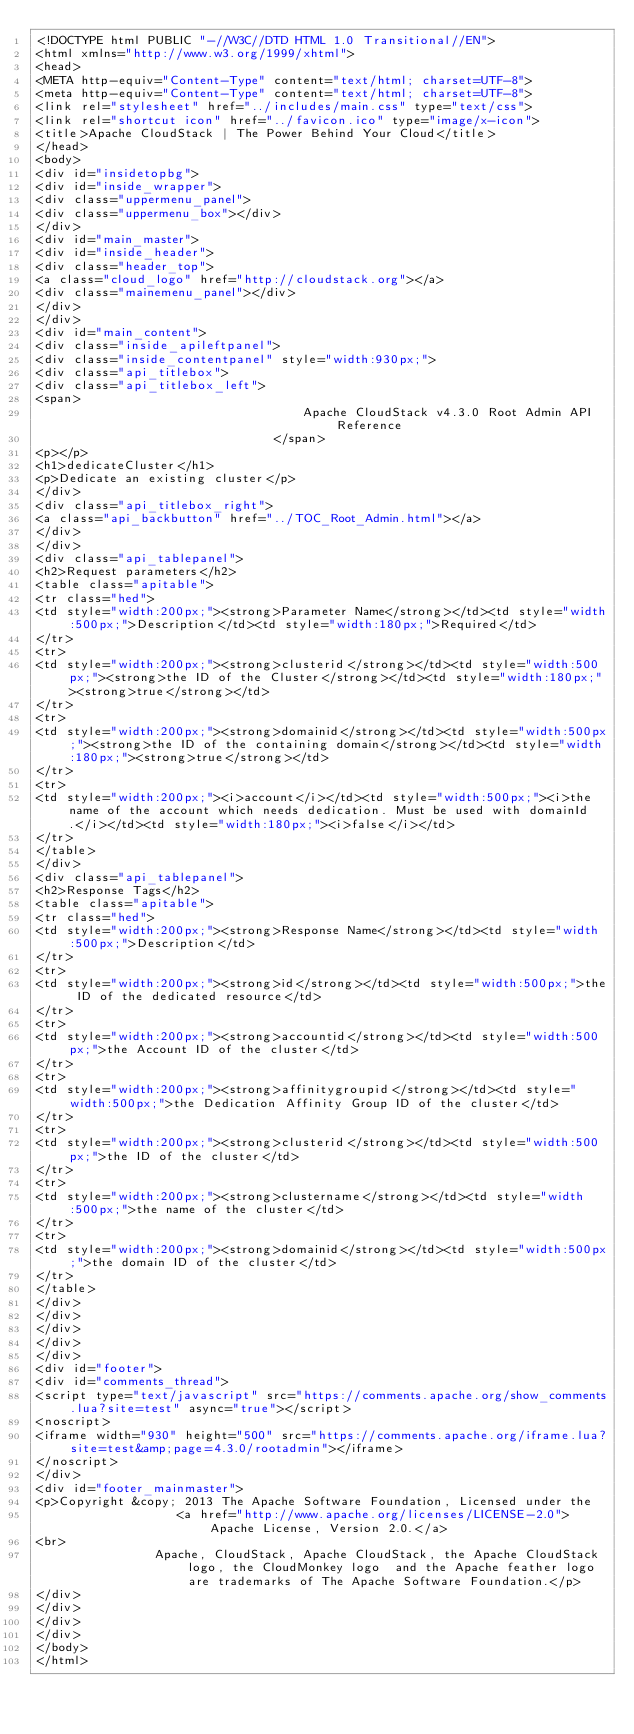Convert code to text. <code><loc_0><loc_0><loc_500><loc_500><_HTML_><!DOCTYPE html PUBLIC "-//W3C//DTD HTML 1.0 Transitional//EN">
<html xmlns="http://www.w3.org/1999/xhtml">
<head>
<META http-equiv="Content-Type" content="text/html; charset=UTF-8">
<meta http-equiv="Content-Type" content="text/html; charset=UTF-8">
<link rel="stylesheet" href="../includes/main.css" type="text/css">
<link rel="shortcut icon" href="../favicon.ico" type="image/x-icon">
<title>Apache CloudStack | The Power Behind Your Cloud</title>
</head>
<body>
<div id="insidetopbg">
<div id="inside_wrapper">
<div class="uppermenu_panel">
<div class="uppermenu_box"></div>
</div>
<div id="main_master">
<div id="inside_header">
<div class="header_top">
<a class="cloud_logo" href="http://cloudstack.org"></a>
<div class="mainemenu_panel"></div>
</div>
</div>
<div id="main_content">
<div class="inside_apileftpanel">
<div class="inside_contentpanel" style="width:930px;">
<div class="api_titlebox">
<div class="api_titlebox_left">
<span>
									Apache CloudStack v4.3.0 Root Admin API Reference
								</span>
<p></p>
<h1>dedicateCluster</h1>
<p>Dedicate an existing cluster</p>
</div>
<div class="api_titlebox_right">
<a class="api_backbutton" href="../TOC_Root_Admin.html"></a>
</div>
</div>
<div class="api_tablepanel">
<h2>Request parameters</h2>
<table class="apitable">
<tr class="hed">
<td style="width:200px;"><strong>Parameter Name</strong></td><td style="width:500px;">Description</td><td style="width:180px;">Required</td>
</tr>
<tr>
<td style="width:200px;"><strong>clusterid</strong></td><td style="width:500px;"><strong>the ID of the Cluster</strong></td><td style="width:180px;"><strong>true</strong></td>
</tr>
<tr>
<td style="width:200px;"><strong>domainid</strong></td><td style="width:500px;"><strong>the ID of the containing domain</strong></td><td style="width:180px;"><strong>true</strong></td>
</tr>
<tr>
<td style="width:200px;"><i>account</i></td><td style="width:500px;"><i>the name of the account which needs dedication. Must be used with domainId.</i></td><td style="width:180px;"><i>false</i></td>
</tr>
</table>
</div>
<div class="api_tablepanel">
<h2>Response Tags</h2>
<table class="apitable">
<tr class="hed">
<td style="width:200px;"><strong>Response Name</strong></td><td style="width:500px;">Description</td>
</tr>
<tr>
<td style="width:200px;"><strong>id</strong></td><td style="width:500px;">the ID of the dedicated resource</td>
</tr>
<tr>
<td style="width:200px;"><strong>accountid</strong></td><td style="width:500px;">the Account ID of the cluster</td>
</tr>
<tr>
<td style="width:200px;"><strong>affinitygroupid</strong></td><td style="width:500px;">the Dedication Affinity Group ID of the cluster</td>
</tr>
<tr>
<td style="width:200px;"><strong>clusterid</strong></td><td style="width:500px;">the ID of the cluster</td>
</tr>
<tr>
<td style="width:200px;"><strong>clustername</strong></td><td style="width:500px;">the name of the cluster</td>
</tr>
<tr>
<td style="width:200px;"><strong>domainid</strong></td><td style="width:500px;">the domain ID of the cluster</td>
</tr>
</table>
</div>
</div>
</div>
</div>
</div>
<div id="footer">
<div id="comments_thread">
<script type="text/javascript" src="https://comments.apache.org/show_comments.lua?site=test" async="true"></script>
<noscript>
<iframe width="930" height="500" src="https://comments.apache.org/iframe.lua?site=test&amp;page=4.3.0/rootadmin"></iframe>
</noscript>
</div>
<div id="footer_mainmaster">
<p>Copyright &copy; 2013 The Apache Software Foundation, Licensed under the
                   <a href="http://www.apache.org/licenses/LICENSE-2.0">Apache License, Version 2.0.</a>
<br>
                Apache, CloudStack, Apache CloudStack, the Apache CloudStack logo, the CloudMonkey logo  and the Apache feather logo are trademarks of The Apache Software Foundation.</p>
</div>
</div>
</div>
</div>
</body>
</html>
</code> 